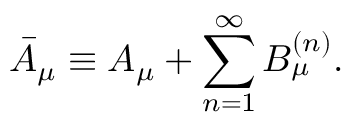Convert formula to latex. <formula><loc_0><loc_0><loc_500><loc_500>\bar { A } _ { \mu } \equiv A _ { \mu } + \sum _ { n = 1 } ^ { \infty } B _ { \mu } ^ { ( n ) } .</formula> 